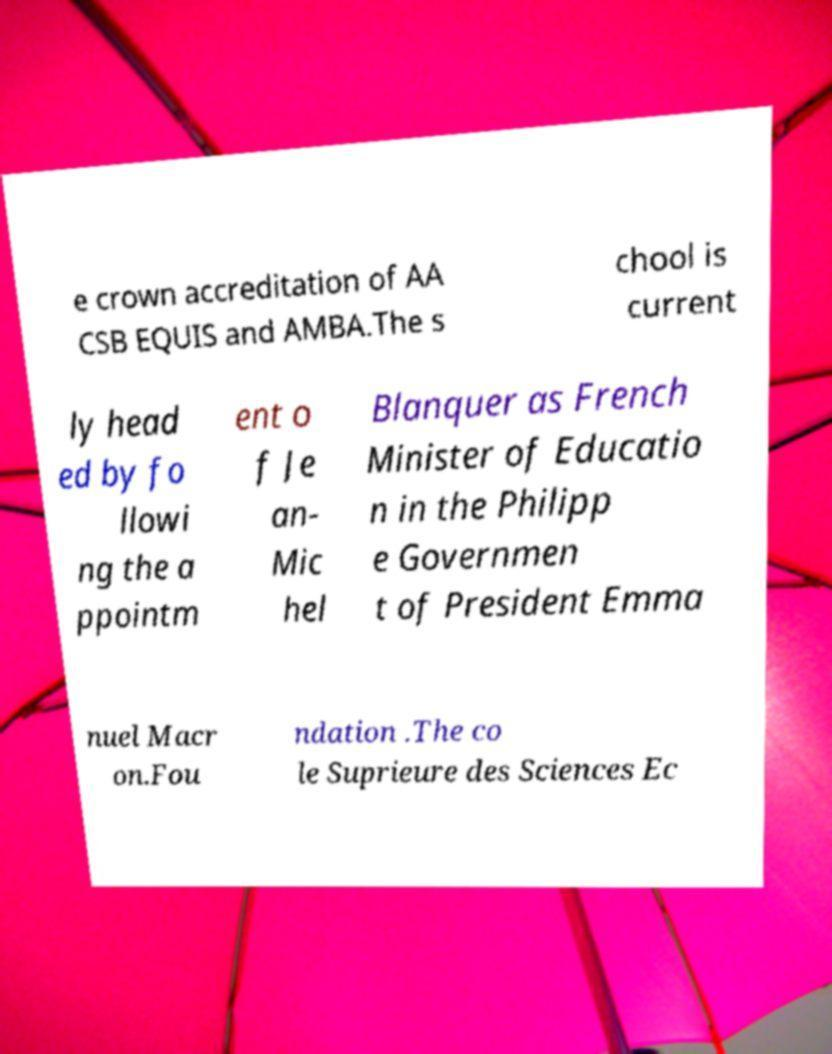What messages or text are displayed in this image? I need them in a readable, typed format. e crown accreditation of AA CSB EQUIS and AMBA.The s chool is current ly head ed by fo llowi ng the a ppointm ent o f Je an- Mic hel Blanquer as French Minister of Educatio n in the Philipp e Governmen t of President Emma nuel Macr on.Fou ndation .The co le Suprieure des Sciences Ec 